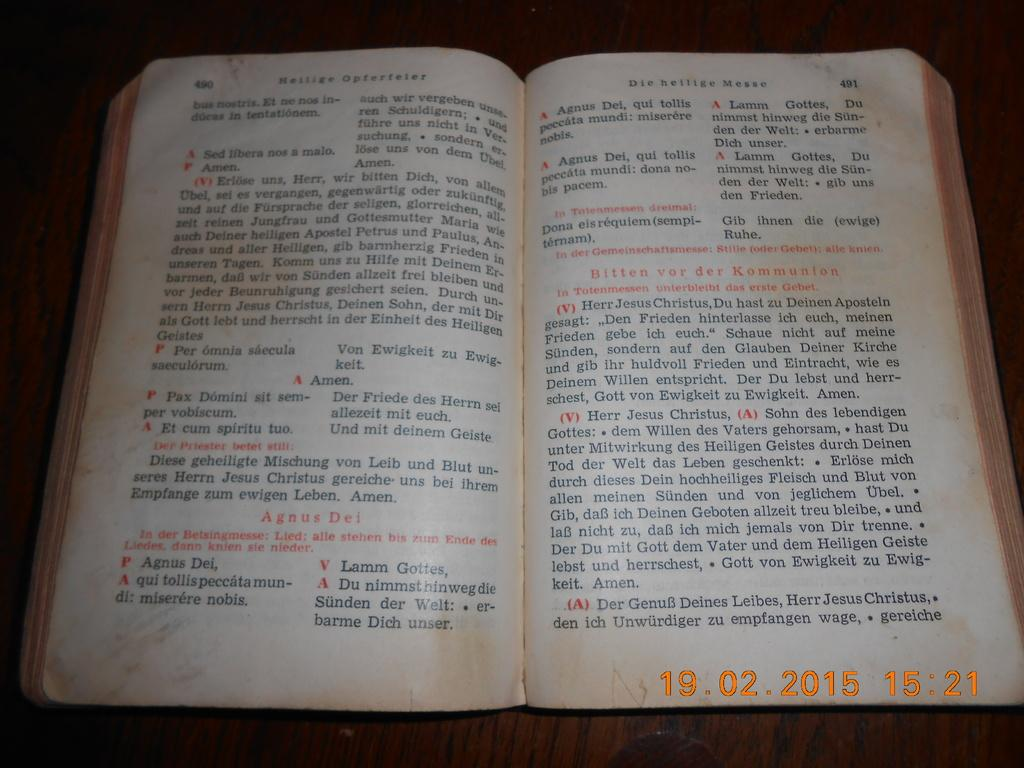Provide a one-sentence caption for the provided image. An old book in dutch text with the passage pertaining to Bitten vor der Kommunion. 